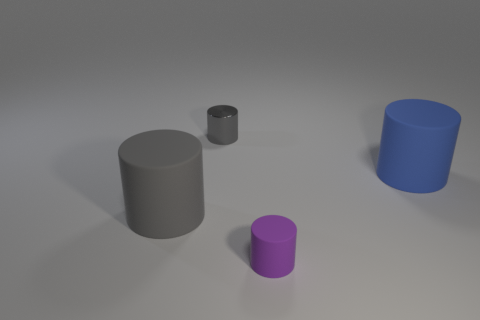Is there anything else that is the same material as the tiny gray thing?
Your answer should be compact. No. Are there any big gray rubber objects of the same shape as the purple rubber thing?
Provide a succinct answer. Yes. There is another cylinder that is the same size as the purple cylinder; what material is it?
Provide a short and direct response. Metal. How big is the gray cylinder that is behind the blue object?
Your response must be concise. Small. There is a gray cylinder behind the large blue rubber object; is its size the same as the matte cylinder to the right of the tiny purple object?
Provide a succinct answer. No. How many other tiny cylinders are the same material as the purple cylinder?
Provide a succinct answer. 0. What is the color of the small rubber thing?
Give a very brief answer. Purple. There is a big blue object; are there any small matte things in front of it?
Provide a succinct answer. Yes. How many big rubber objects have the same color as the shiny object?
Provide a short and direct response. 1. How big is the matte object that is in front of the rubber cylinder on the left side of the metal thing?
Your answer should be compact. Small. 